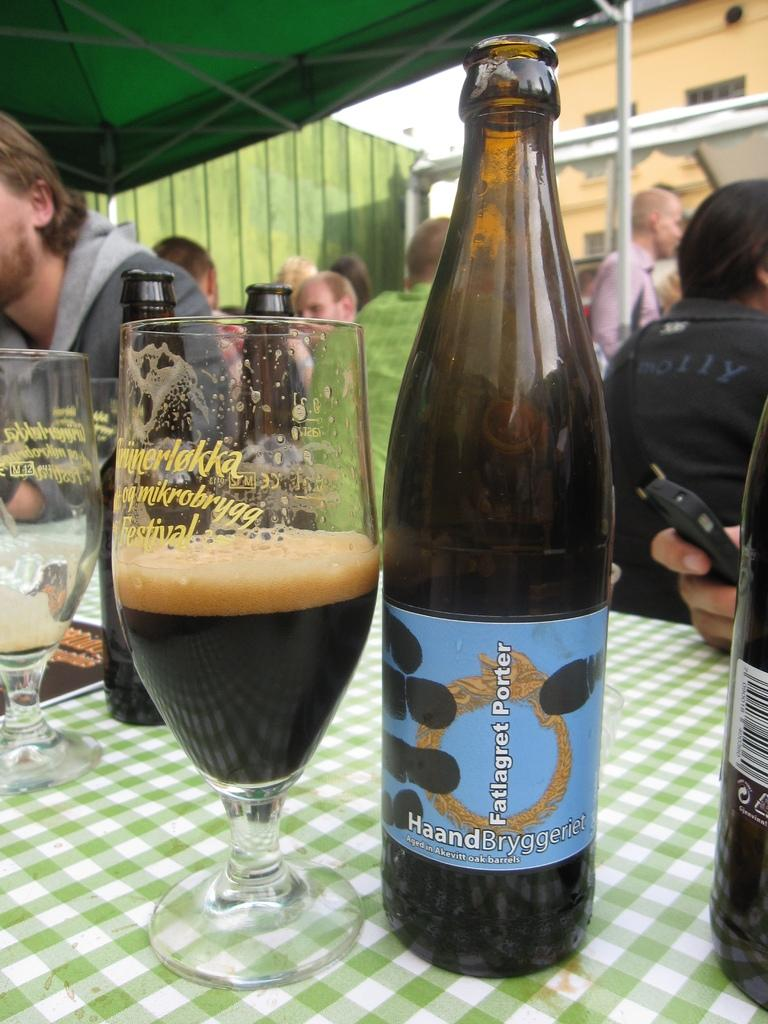What are the people in the image doing? There is a group of people sitting in the image. What can be seen on the table in the image? There is a glass with a drink in it and a bottle on the table. What is the background of the image like? There is a wall and an umbrella in the background of the image. What type of education can be seen in the image? There is no reference to education in the image; it features a group of people sitting and a table with a glass and a bottle. What kind of patch is visible on the body of the person in the image? There is no person with a visible patch in the image; it only shows a group of people sitting and a table with a glass and a bottle. 